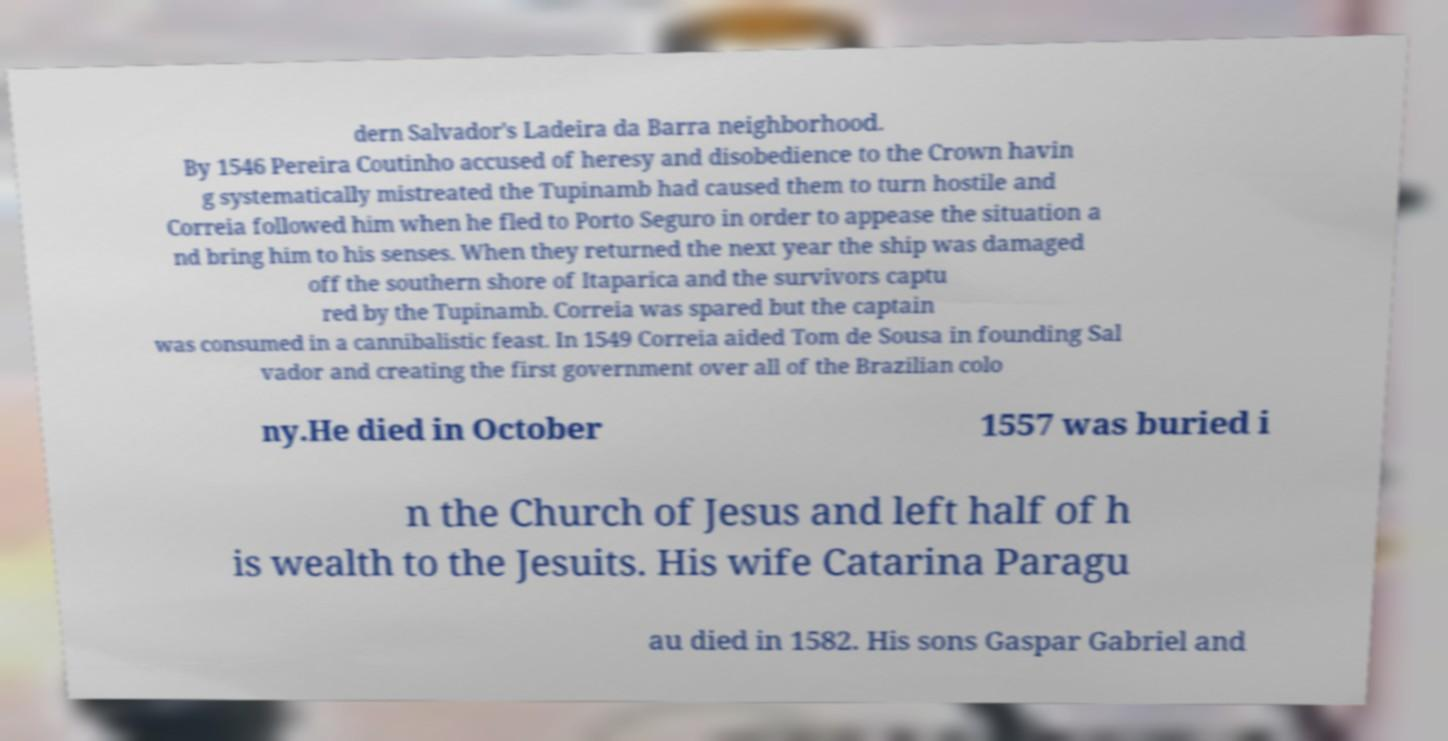Can you read and provide the text displayed in the image?This photo seems to have some interesting text. Can you extract and type it out for me? dern Salvador's Ladeira da Barra neighborhood. By 1546 Pereira Coutinho accused of heresy and disobedience to the Crown havin g systematically mistreated the Tupinamb had caused them to turn hostile and Correia followed him when he fled to Porto Seguro in order to appease the situation a nd bring him to his senses. When they returned the next year the ship was damaged off the southern shore of Itaparica and the survivors captu red by the Tupinamb. Correia was spared but the captain was consumed in a cannibalistic feast. In 1549 Correia aided Tom de Sousa in founding Sal vador and creating the first government over all of the Brazilian colo ny.He died in October 1557 was buried i n the Church of Jesus and left half of h is wealth to the Jesuits. His wife Catarina Paragu au died in 1582. His sons Gaspar Gabriel and 